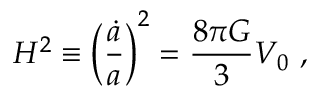<formula> <loc_0><loc_0><loc_500><loc_500>H ^ { 2 } \equiv \left ( \frac { \dot { a } } { a } \right ) ^ { 2 } = \frac { 8 \pi G } { 3 } V _ { 0 } ,</formula> 